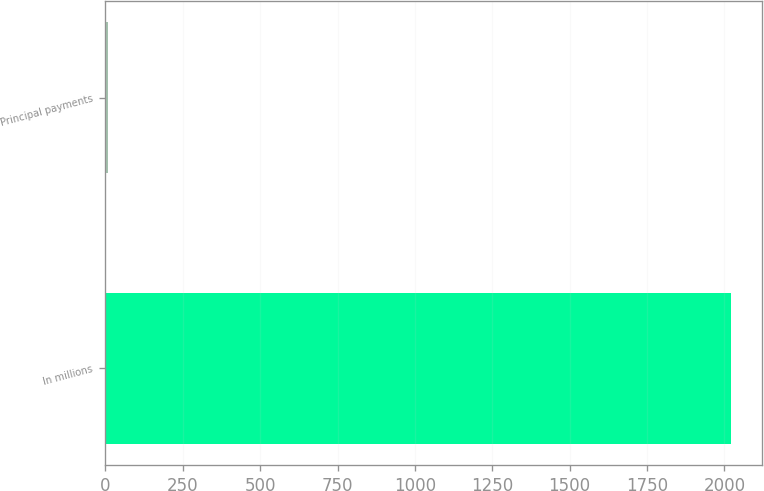Convert chart to OTSL. <chart><loc_0><loc_0><loc_500><loc_500><bar_chart><fcel>In millions<fcel>Principal payments<nl><fcel>2020<fcel>8<nl></chart> 